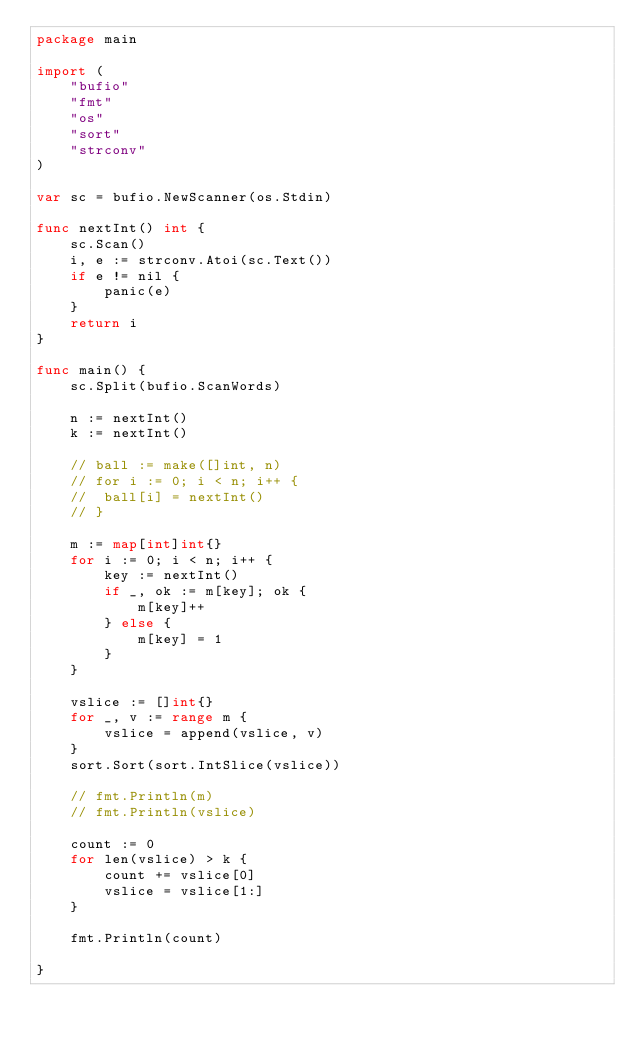Convert code to text. <code><loc_0><loc_0><loc_500><loc_500><_Go_>package main

import (
	"bufio"
	"fmt"
	"os"
	"sort"
	"strconv"
)

var sc = bufio.NewScanner(os.Stdin)

func nextInt() int {
	sc.Scan()
	i, e := strconv.Atoi(sc.Text())
	if e != nil {
		panic(e)
	}
	return i
}

func main() {
	sc.Split(bufio.ScanWords)

	n := nextInt()
	k := nextInt()

	// ball := make([]int, n)
	// for i := 0; i < n; i++ {
	// 	ball[i] = nextInt()
	// }

	m := map[int]int{}
	for i := 0; i < n; i++ {
		key := nextInt()
		if _, ok := m[key]; ok {
			m[key]++
		} else {
			m[key] = 1
		}
	}

	vslice := []int{}
	for _, v := range m {
		vslice = append(vslice, v)
	}
	sort.Sort(sort.IntSlice(vslice))

	// fmt.Println(m)
	// fmt.Println(vslice)

	count := 0
	for len(vslice) > k {
		count += vslice[0]
		vslice = vslice[1:]
	}

	fmt.Println(count)

}
</code> 